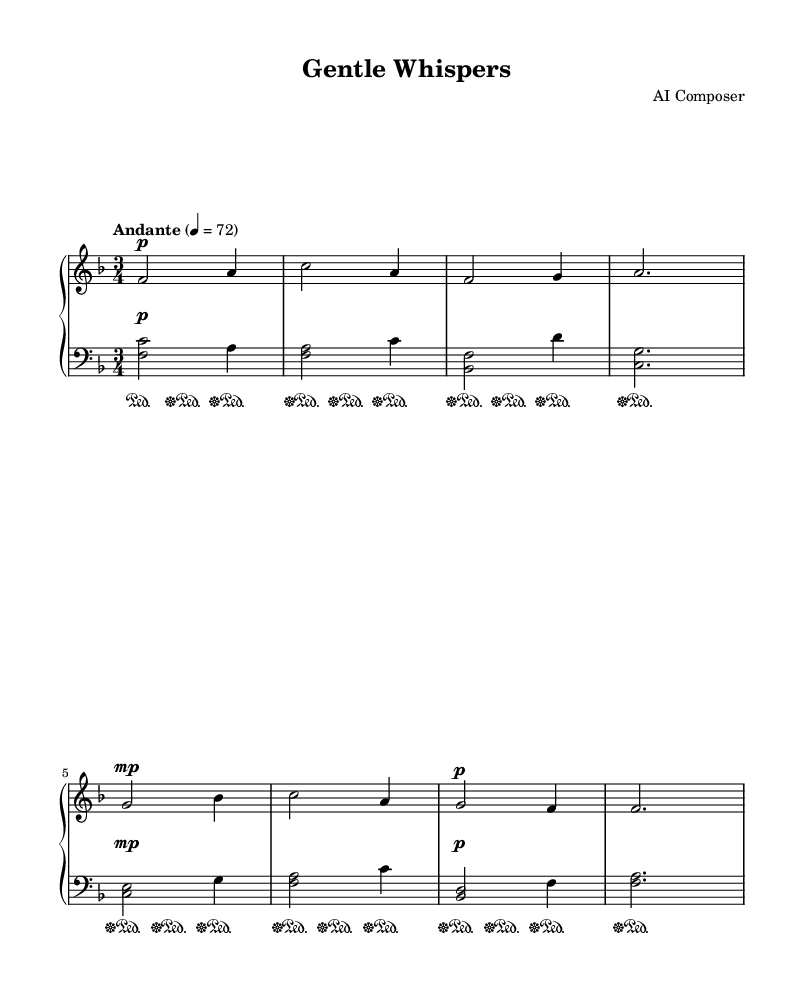What is the key signature of this music? The key signature of the piece can be found at the beginning of the staff. It shows one flat, which indicates that the key is F major.
Answer: F major What is the time signature of this music? The time signature is indicated by two numbers at the beginning of the music sheet, specifically 3/4, meaning there are three beats in each measure and the quarter note gets one beat.
Answer: 3/4 What is the tempo marking for this piece? The tempo marking is located near the top of the music sheet where it states "Andante," which indicates a moderate pace. The number "4 = 72" specifies the beats per minute.
Answer: Andante How many measures are in the piece? By counting the distinct separated sections within the staff lines that contain notes, there are a total of 8 measures in this piece.
Answer: 8 measures What is the dynamic marking for the first section of the right hand? The dynamic marking shown right after the first note in the right-hand part is "p," indicating that this section is to be played softly.
Answer: p What is the main characteristic of the left hand's part in terms of harmony? The left-hand part consists mainly of chordal structures, as indicated by the use of stacked notes played together to create a harmonic foundation throughout the piece.
Answer: Chordal structures Which technique is specified for pedal usage in the music? The indications for pedal usage are shown at regular intervals throughout the music, with "sustainOn" and "sustainOff" markings, specifying when to press and release the pedal for smoother sound transitions.
Answer: Pedal markings 